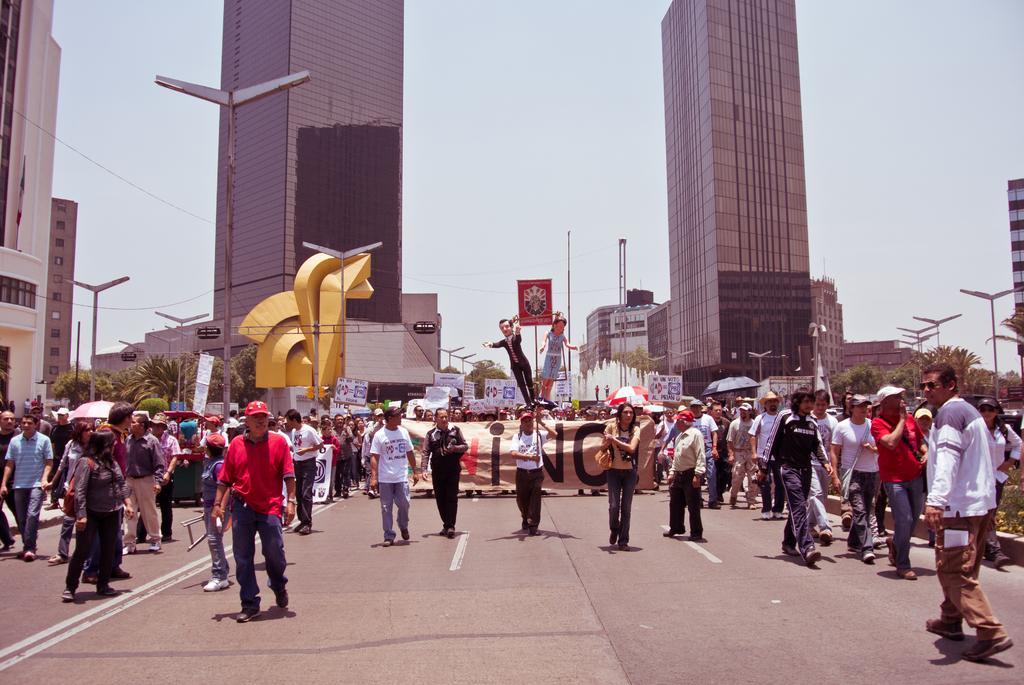Describe this image in one or two sentences. In this image, we can see persons wearing clothes. There is a banner and some buildings in the middle of the image. There are street poles on the left and on the right side of the image. There is a road in between trees. In the background, we can see the sky. 